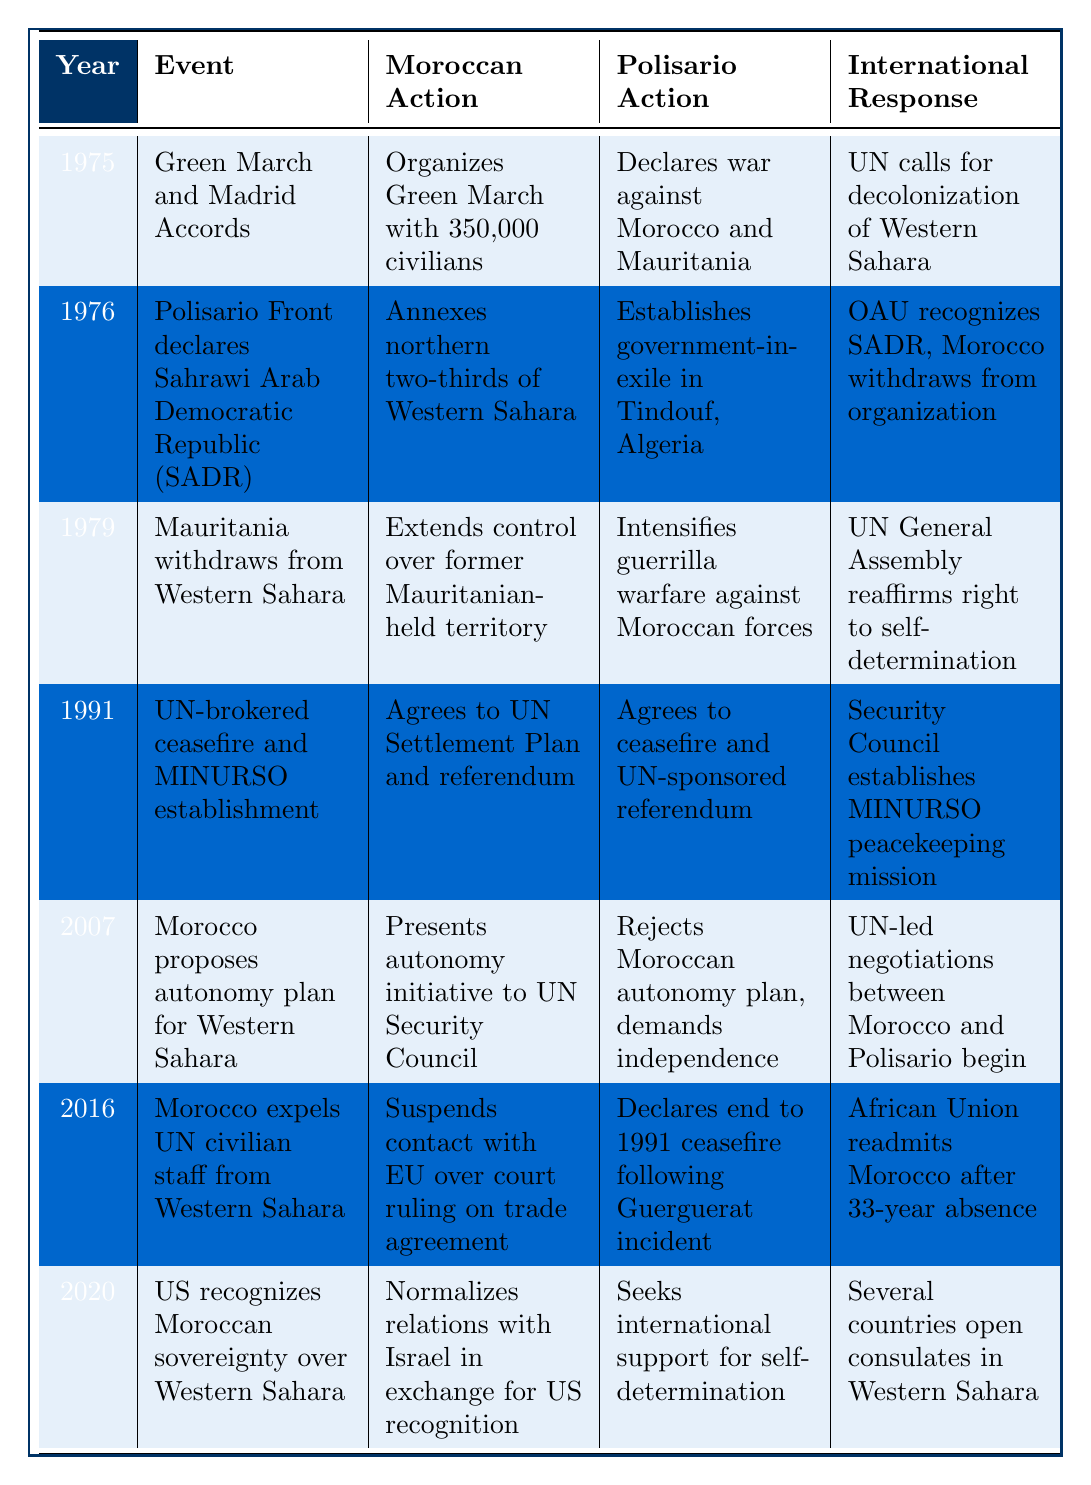What event occurred in 1991? According to the table, in 1991, a UN-brokered ceasefire was established, and the MINURSO peacekeeping mission was formed.
Answer: UN-brokered ceasefire and MINURSO establishment What Moroccan action was taken in 1979? The table indicates that in 1979, Morocco extended control over former Mauritanian-held territory.
Answer: Extends control over former Mauritanian-held territory Did the Polisario Front establish a government-in-exile? Yes, the table states that in 1976, the Polisario Front established a government-in-exile in Tindouf, Algeria.
Answer: Yes What was the international response to Morocco's actions in 2007? The table shows that in 2007, the international response involved UN-led negotiations beginning between Morocco and the Polisario Front.
Answer: UN-led negotiations between Morocco and Polisario begin In which year did the US recognize Moroccan sovereignty over Western Sahara? The table lists that the US recognized Moroccan sovereignty in 2020.
Answer: 2020 What is the difference in the Moroccan actions taken between 1975 and 2007? The Moroccan actions in 1975 included organizing the Green March, while in 2007, Morocco proposed an autonomy plan for Western Sahara. Both actions reflect strategic territorial moves but span a 32-year difference.
Answer: 32 years Was there a ceasefire declared before the establishment of MINURSO? Yes, the table indicates that a ceasefire was agreed upon before the establishment of MINURSO in 1991.
Answer: Yes What series of events lead to Morocco’s suspension of contacts with the EU in 2016? In 2016, Morocco suspended contact with the EU over a court ruling on a trade agreement following its expulsion of UN civilian staff from Western Sahara, illustrating a response to perceived legal grievances.
Answer: Expulsion of UN staff and subsequent suspension of EU contact Which year saw Morocco propose an autonomy initiative, and what was the international response? In 2007, Morocco proposed an autonomy initiative, and the international response was the beginning of UN-led negotiations between Morocco and the Polisario Front.
Answer: 2007; UN-led negotiations begin What were the Moroccan actions from 1975 to 2020, and how did they change over time? The table outlines a progression from organizing the Green March in 1975 aimed at territorial expansion to the proposal of an autonomy plan in 2007 and normalizing relations with Israel in exchange for US recognition in 2020, showcasing a shift from direct territorial claims to diplomatic negotiations.
Answer: Shift from military actions to diplomatic strategies over time 